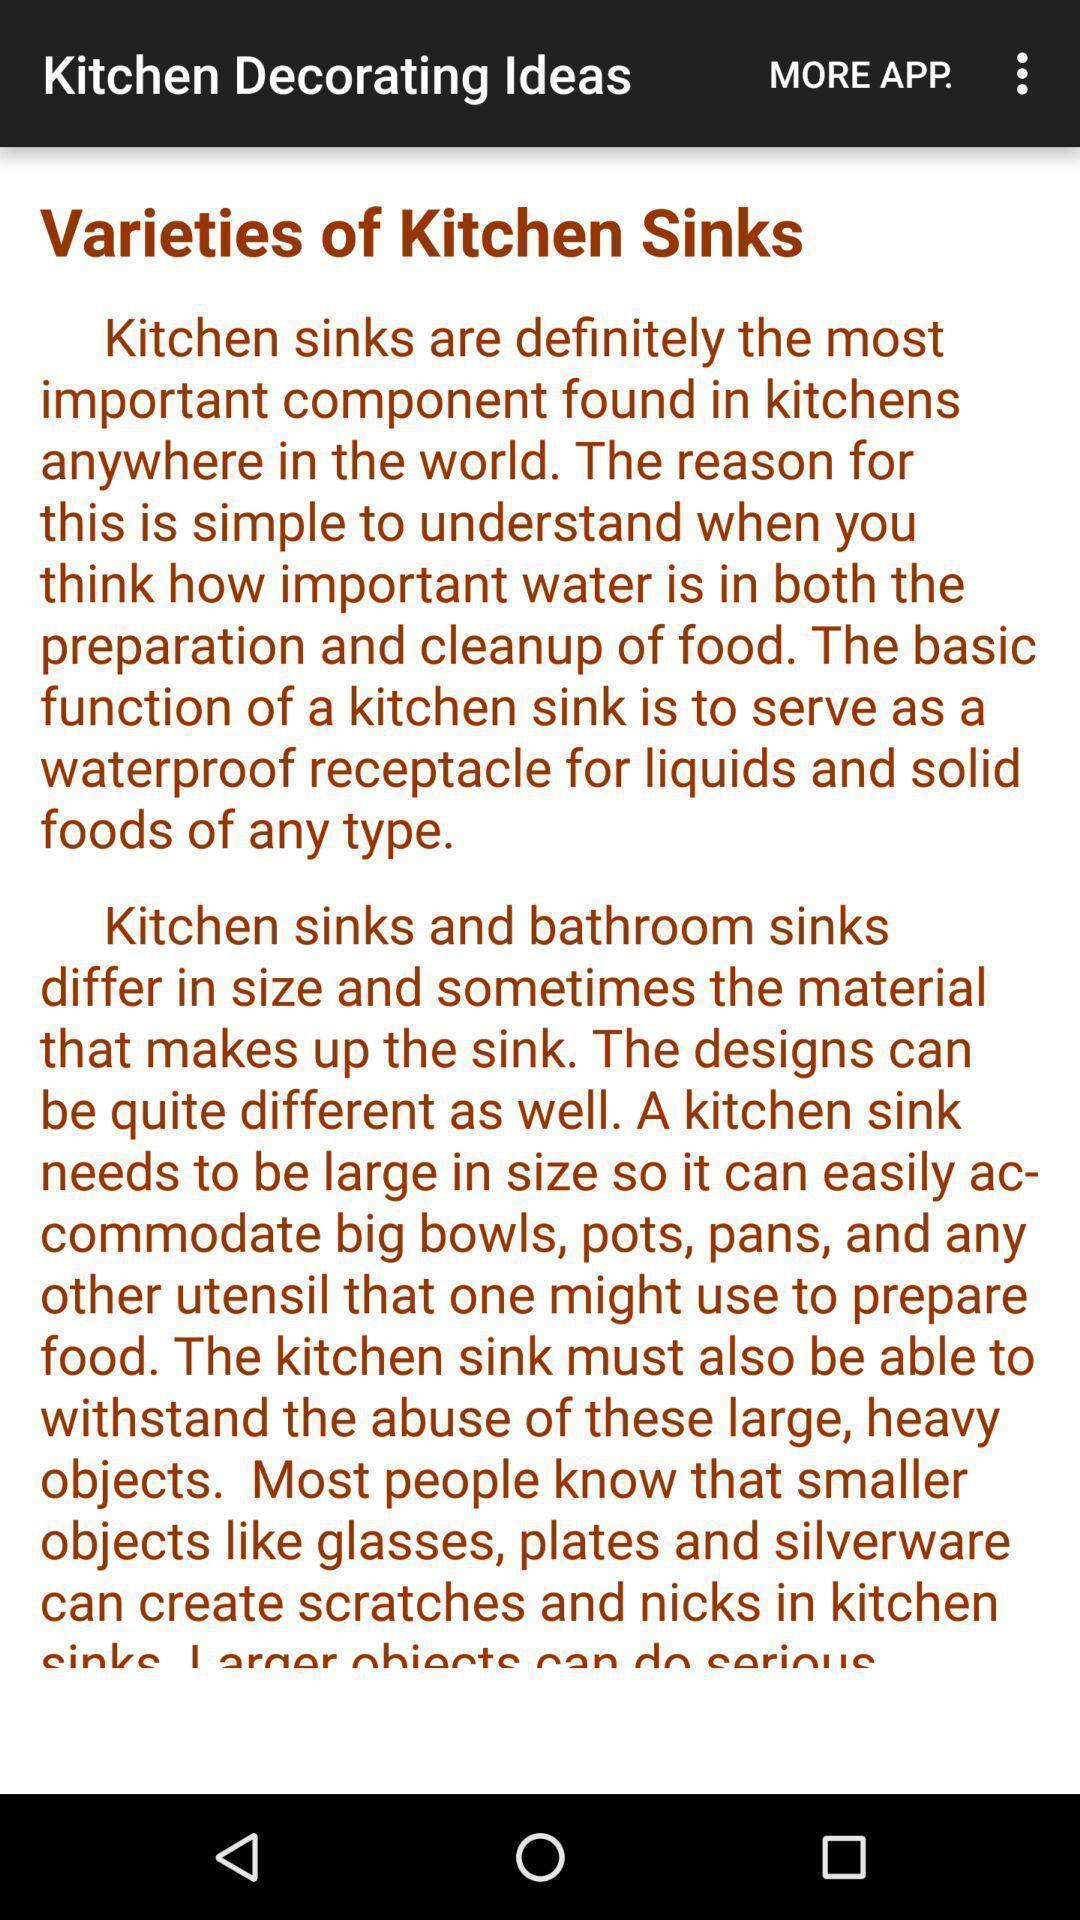Explain the elements present in this screenshot. Page showing statement of kitchen design app. 